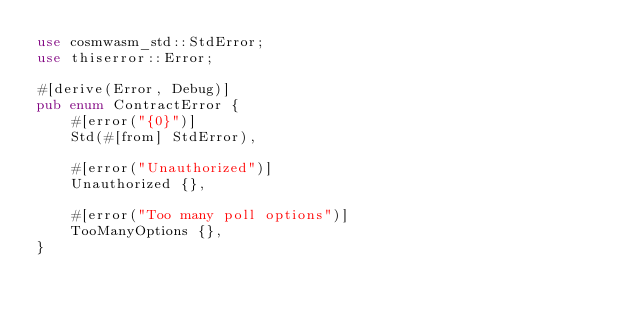Convert code to text. <code><loc_0><loc_0><loc_500><loc_500><_Rust_>use cosmwasm_std::StdError;
use thiserror::Error;

#[derive(Error, Debug)]
pub enum ContractError {
    #[error("{0}")]
    Std(#[from] StdError),

    #[error("Unauthorized")]
    Unauthorized {},

    #[error("Too many poll options")]
    TooManyOptions {},
}</code> 